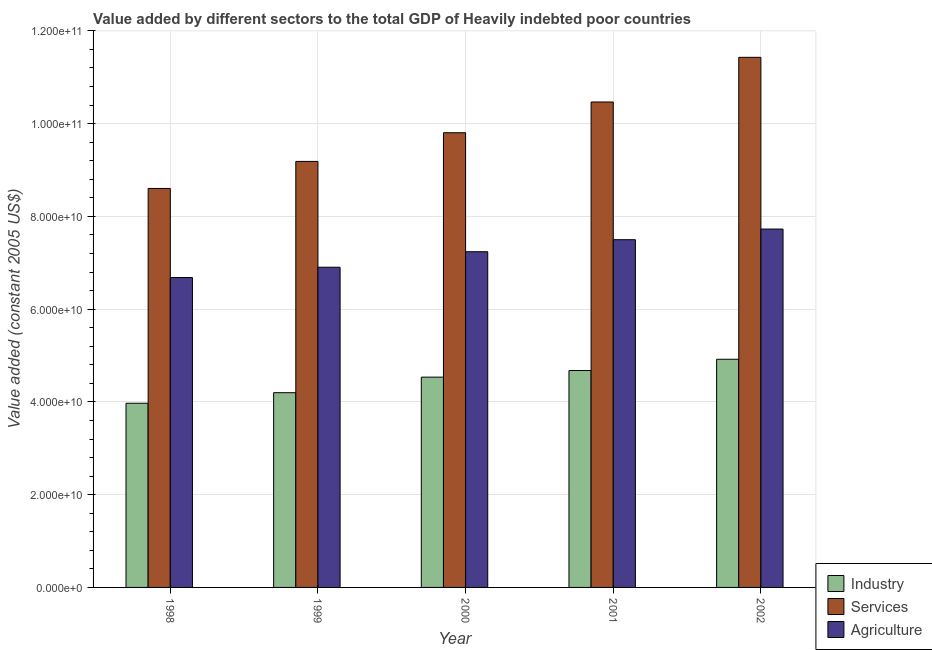How many different coloured bars are there?
Offer a terse response. 3. Are the number of bars per tick equal to the number of legend labels?
Ensure brevity in your answer.  Yes. Are the number of bars on each tick of the X-axis equal?
Your answer should be compact. Yes. What is the label of the 5th group of bars from the left?
Your answer should be very brief. 2002. What is the value added by agricultural sector in 1998?
Provide a succinct answer. 6.68e+1. Across all years, what is the maximum value added by industrial sector?
Make the answer very short. 4.92e+1. Across all years, what is the minimum value added by services?
Your answer should be very brief. 8.60e+1. In which year was the value added by services maximum?
Your response must be concise. 2002. In which year was the value added by industrial sector minimum?
Offer a very short reply. 1998. What is the total value added by agricultural sector in the graph?
Offer a very short reply. 3.60e+11. What is the difference between the value added by agricultural sector in 1999 and that in 2002?
Give a very brief answer. -8.23e+09. What is the difference between the value added by services in 2000 and the value added by agricultural sector in 1999?
Your response must be concise. 6.18e+09. What is the average value added by industrial sector per year?
Offer a terse response. 4.46e+1. In the year 2001, what is the difference between the value added by agricultural sector and value added by services?
Provide a short and direct response. 0. What is the ratio of the value added by industrial sector in 1998 to that in 2000?
Offer a terse response. 0.88. Is the value added by agricultural sector in 1998 less than that in 2001?
Provide a short and direct response. Yes. What is the difference between the highest and the second highest value added by industrial sector?
Provide a short and direct response. 2.43e+09. What is the difference between the highest and the lowest value added by industrial sector?
Provide a succinct answer. 9.49e+09. In how many years, is the value added by industrial sector greater than the average value added by industrial sector taken over all years?
Make the answer very short. 3. What does the 2nd bar from the left in 1999 represents?
Ensure brevity in your answer.  Services. What does the 1st bar from the right in 1999 represents?
Offer a very short reply. Agriculture. Is it the case that in every year, the sum of the value added by industrial sector and value added by services is greater than the value added by agricultural sector?
Give a very brief answer. Yes. Are all the bars in the graph horizontal?
Offer a very short reply. No. Are the values on the major ticks of Y-axis written in scientific E-notation?
Provide a short and direct response. Yes. Does the graph contain grids?
Your answer should be compact. Yes. How many legend labels are there?
Keep it short and to the point. 3. What is the title of the graph?
Your answer should be compact. Value added by different sectors to the total GDP of Heavily indebted poor countries. What is the label or title of the X-axis?
Make the answer very short. Year. What is the label or title of the Y-axis?
Ensure brevity in your answer.  Value added (constant 2005 US$). What is the Value added (constant 2005 US$) in Industry in 1998?
Offer a terse response. 3.97e+1. What is the Value added (constant 2005 US$) in Services in 1998?
Your response must be concise. 8.60e+1. What is the Value added (constant 2005 US$) of Agriculture in 1998?
Your answer should be very brief. 6.68e+1. What is the Value added (constant 2005 US$) in Industry in 1999?
Make the answer very short. 4.20e+1. What is the Value added (constant 2005 US$) in Services in 1999?
Ensure brevity in your answer.  9.19e+1. What is the Value added (constant 2005 US$) in Agriculture in 1999?
Offer a very short reply. 6.90e+1. What is the Value added (constant 2005 US$) of Industry in 2000?
Offer a terse response. 4.53e+1. What is the Value added (constant 2005 US$) in Services in 2000?
Offer a terse response. 9.80e+1. What is the Value added (constant 2005 US$) in Agriculture in 2000?
Offer a very short reply. 7.24e+1. What is the Value added (constant 2005 US$) in Industry in 2001?
Ensure brevity in your answer.  4.68e+1. What is the Value added (constant 2005 US$) in Services in 2001?
Give a very brief answer. 1.05e+11. What is the Value added (constant 2005 US$) in Agriculture in 2001?
Provide a succinct answer. 7.50e+1. What is the Value added (constant 2005 US$) of Industry in 2002?
Your response must be concise. 4.92e+1. What is the Value added (constant 2005 US$) of Services in 2002?
Provide a succinct answer. 1.14e+11. What is the Value added (constant 2005 US$) in Agriculture in 2002?
Ensure brevity in your answer.  7.73e+1. Across all years, what is the maximum Value added (constant 2005 US$) of Industry?
Give a very brief answer. 4.92e+1. Across all years, what is the maximum Value added (constant 2005 US$) of Services?
Make the answer very short. 1.14e+11. Across all years, what is the maximum Value added (constant 2005 US$) in Agriculture?
Offer a very short reply. 7.73e+1. Across all years, what is the minimum Value added (constant 2005 US$) of Industry?
Your response must be concise. 3.97e+1. Across all years, what is the minimum Value added (constant 2005 US$) of Services?
Keep it short and to the point. 8.60e+1. Across all years, what is the minimum Value added (constant 2005 US$) in Agriculture?
Provide a succinct answer. 6.68e+1. What is the total Value added (constant 2005 US$) of Industry in the graph?
Your answer should be very brief. 2.23e+11. What is the total Value added (constant 2005 US$) of Services in the graph?
Your response must be concise. 4.95e+11. What is the total Value added (constant 2005 US$) in Agriculture in the graph?
Offer a very short reply. 3.60e+11. What is the difference between the Value added (constant 2005 US$) in Industry in 1998 and that in 1999?
Provide a short and direct response. -2.28e+09. What is the difference between the Value added (constant 2005 US$) of Services in 1998 and that in 1999?
Provide a succinct answer. -5.83e+09. What is the difference between the Value added (constant 2005 US$) in Agriculture in 1998 and that in 1999?
Ensure brevity in your answer.  -2.22e+09. What is the difference between the Value added (constant 2005 US$) in Industry in 1998 and that in 2000?
Your answer should be very brief. -5.63e+09. What is the difference between the Value added (constant 2005 US$) of Services in 1998 and that in 2000?
Offer a very short reply. -1.20e+1. What is the difference between the Value added (constant 2005 US$) of Agriculture in 1998 and that in 2000?
Your response must be concise. -5.57e+09. What is the difference between the Value added (constant 2005 US$) of Industry in 1998 and that in 2001?
Keep it short and to the point. -7.06e+09. What is the difference between the Value added (constant 2005 US$) in Services in 1998 and that in 2001?
Offer a terse response. -1.86e+1. What is the difference between the Value added (constant 2005 US$) of Agriculture in 1998 and that in 2001?
Offer a terse response. -8.16e+09. What is the difference between the Value added (constant 2005 US$) in Industry in 1998 and that in 2002?
Your answer should be compact. -9.49e+09. What is the difference between the Value added (constant 2005 US$) of Services in 1998 and that in 2002?
Make the answer very short. -2.83e+1. What is the difference between the Value added (constant 2005 US$) in Agriculture in 1998 and that in 2002?
Provide a short and direct response. -1.05e+1. What is the difference between the Value added (constant 2005 US$) of Industry in 1999 and that in 2000?
Your response must be concise. -3.35e+09. What is the difference between the Value added (constant 2005 US$) in Services in 1999 and that in 2000?
Keep it short and to the point. -6.18e+09. What is the difference between the Value added (constant 2005 US$) of Agriculture in 1999 and that in 2000?
Your response must be concise. -3.34e+09. What is the difference between the Value added (constant 2005 US$) in Industry in 1999 and that in 2001?
Your answer should be very brief. -4.78e+09. What is the difference between the Value added (constant 2005 US$) of Services in 1999 and that in 2001?
Provide a succinct answer. -1.28e+1. What is the difference between the Value added (constant 2005 US$) in Agriculture in 1999 and that in 2001?
Your answer should be very brief. -5.93e+09. What is the difference between the Value added (constant 2005 US$) of Industry in 1999 and that in 2002?
Give a very brief answer. -7.21e+09. What is the difference between the Value added (constant 2005 US$) of Services in 1999 and that in 2002?
Offer a terse response. -2.24e+1. What is the difference between the Value added (constant 2005 US$) of Agriculture in 1999 and that in 2002?
Provide a short and direct response. -8.23e+09. What is the difference between the Value added (constant 2005 US$) of Industry in 2000 and that in 2001?
Offer a terse response. -1.43e+09. What is the difference between the Value added (constant 2005 US$) in Services in 2000 and that in 2001?
Give a very brief answer. -6.63e+09. What is the difference between the Value added (constant 2005 US$) of Agriculture in 2000 and that in 2001?
Provide a succinct answer. -2.59e+09. What is the difference between the Value added (constant 2005 US$) in Industry in 2000 and that in 2002?
Provide a succinct answer. -3.85e+09. What is the difference between the Value added (constant 2005 US$) in Services in 2000 and that in 2002?
Offer a very short reply. -1.63e+1. What is the difference between the Value added (constant 2005 US$) in Agriculture in 2000 and that in 2002?
Offer a very short reply. -4.89e+09. What is the difference between the Value added (constant 2005 US$) in Industry in 2001 and that in 2002?
Keep it short and to the point. -2.43e+09. What is the difference between the Value added (constant 2005 US$) of Services in 2001 and that in 2002?
Your answer should be compact. -9.63e+09. What is the difference between the Value added (constant 2005 US$) in Agriculture in 2001 and that in 2002?
Offer a very short reply. -2.30e+09. What is the difference between the Value added (constant 2005 US$) of Industry in 1998 and the Value added (constant 2005 US$) of Services in 1999?
Ensure brevity in your answer.  -5.21e+1. What is the difference between the Value added (constant 2005 US$) of Industry in 1998 and the Value added (constant 2005 US$) of Agriculture in 1999?
Offer a very short reply. -2.93e+1. What is the difference between the Value added (constant 2005 US$) of Services in 1998 and the Value added (constant 2005 US$) of Agriculture in 1999?
Provide a succinct answer. 1.70e+1. What is the difference between the Value added (constant 2005 US$) in Industry in 1998 and the Value added (constant 2005 US$) in Services in 2000?
Provide a succinct answer. -5.83e+1. What is the difference between the Value added (constant 2005 US$) in Industry in 1998 and the Value added (constant 2005 US$) in Agriculture in 2000?
Keep it short and to the point. -3.27e+1. What is the difference between the Value added (constant 2005 US$) in Services in 1998 and the Value added (constant 2005 US$) in Agriculture in 2000?
Make the answer very short. 1.36e+1. What is the difference between the Value added (constant 2005 US$) of Industry in 1998 and the Value added (constant 2005 US$) of Services in 2001?
Offer a very short reply. -6.50e+1. What is the difference between the Value added (constant 2005 US$) in Industry in 1998 and the Value added (constant 2005 US$) in Agriculture in 2001?
Offer a very short reply. -3.53e+1. What is the difference between the Value added (constant 2005 US$) in Services in 1998 and the Value added (constant 2005 US$) in Agriculture in 2001?
Your answer should be very brief. 1.11e+1. What is the difference between the Value added (constant 2005 US$) in Industry in 1998 and the Value added (constant 2005 US$) in Services in 2002?
Provide a succinct answer. -7.46e+1. What is the difference between the Value added (constant 2005 US$) in Industry in 1998 and the Value added (constant 2005 US$) in Agriculture in 2002?
Provide a short and direct response. -3.76e+1. What is the difference between the Value added (constant 2005 US$) in Services in 1998 and the Value added (constant 2005 US$) in Agriculture in 2002?
Provide a succinct answer. 8.76e+09. What is the difference between the Value added (constant 2005 US$) of Industry in 1999 and the Value added (constant 2005 US$) of Services in 2000?
Keep it short and to the point. -5.60e+1. What is the difference between the Value added (constant 2005 US$) of Industry in 1999 and the Value added (constant 2005 US$) of Agriculture in 2000?
Give a very brief answer. -3.04e+1. What is the difference between the Value added (constant 2005 US$) of Services in 1999 and the Value added (constant 2005 US$) of Agriculture in 2000?
Provide a succinct answer. 1.95e+1. What is the difference between the Value added (constant 2005 US$) in Industry in 1999 and the Value added (constant 2005 US$) in Services in 2001?
Your answer should be compact. -6.27e+1. What is the difference between the Value added (constant 2005 US$) of Industry in 1999 and the Value added (constant 2005 US$) of Agriculture in 2001?
Your response must be concise. -3.30e+1. What is the difference between the Value added (constant 2005 US$) of Services in 1999 and the Value added (constant 2005 US$) of Agriculture in 2001?
Offer a very short reply. 1.69e+1. What is the difference between the Value added (constant 2005 US$) of Industry in 1999 and the Value added (constant 2005 US$) of Services in 2002?
Your answer should be very brief. -7.23e+1. What is the difference between the Value added (constant 2005 US$) of Industry in 1999 and the Value added (constant 2005 US$) of Agriculture in 2002?
Provide a succinct answer. -3.53e+1. What is the difference between the Value added (constant 2005 US$) of Services in 1999 and the Value added (constant 2005 US$) of Agriculture in 2002?
Make the answer very short. 1.46e+1. What is the difference between the Value added (constant 2005 US$) of Industry in 2000 and the Value added (constant 2005 US$) of Services in 2001?
Give a very brief answer. -5.93e+1. What is the difference between the Value added (constant 2005 US$) in Industry in 2000 and the Value added (constant 2005 US$) in Agriculture in 2001?
Keep it short and to the point. -2.96e+1. What is the difference between the Value added (constant 2005 US$) of Services in 2000 and the Value added (constant 2005 US$) of Agriculture in 2001?
Ensure brevity in your answer.  2.31e+1. What is the difference between the Value added (constant 2005 US$) of Industry in 2000 and the Value added (constant 2005 US$) of Services in 2002?
Your response must be concise. -6.90e+1. What is the difference between the Value added (constant 2005 US$) of Industry in 2000 and the Value added (constant 2005 US$) of Agriculture in 2002?
Your response must be concise. -3.19e+1. What is the difference between the Value added (constant 2005 US$) in Services in 2000 and the Value added (constant 2005 US$) in Agriculture in 2002?
Your answer should be very brief. 2.08e+1. What is the difference between the Value added (constant 2005 US$) in Industry in 2001 and the Value added (constant 2005 US$) in Services in 2002?
Your answer should be compact. -6.75e+1. What is the difference between the Value added (constant 2005 US$) of Industry in 2001 and the Value added (constant 2005 US$) of Agriculture in 2002?
Your answer should be very brief. -3.05e+1. What is the difference between the Value added (constant 2005 US$) of Services in 2001 and the Value added (constant 2005 US$) of Agriculture in 2002?
Your answer should be compact. 2.74e+1. What is the average Value added (constant 2005 US$) in Industry per year?
Provide a succinct answer. 4.46e+1. What is the average Value added (constant 2005 US$) of Services per year?
Your response must be concise. 9.90e+1. What is the average Value added (constant 2005 US$) in Agriculture per year?
Your response must be concise. 7.21e+1. In the year 1998, what is the difference between the Value added (constant 2005 US$) in Industry and Value added (constant 2005 US$) in Services?
Provide a succinct answer. -4.63e+1. In the year 1998, what is the difference between the Value added (constant 2005 US$) of Industry and Value added (constant 2005 US$) of Agriculture?
Ensure brevity in your answer.  -2.71e+1. In the year 1998, what is the difference between the Value added (constant 2005 US$) of Services and Value added (constant 2005 US$) of Agriculture?
Give a very brief answer. 1.92e+1. In the year 1999, what is the difference between the Value added (constant 2005 US$) of Industry and Value added (constant 2005 US$) of Services?
Offer a very short reply. -4.99e+1. In the year 1999, what is the difference between the Value added (constant 2005 US$) of Industry and Value added (constant 2005 US$) of Agriculture?
Offer a terse response. -2.71e+1. In the year 1999, what is the difference between the Value added (constant 2005 US$) in Services and Value added (constant 2005 US$) in Agriculture?
Offer a very short reply. 2.28e+1. In the year 2000, what is the difference between the Value added (constant 2005 US$) in Industry and Value added (constant 2005 US$) in Services?
Offer a very short reply. -5.27e+1. In the year 2000, what is the difference between the Value added (constant 2005 US$) of Industry and Value added (constant 2005 US$) of Agriculture?
Ensure brevity in your answer.  -2.70e+1. In the year 2000, what is the difference between the Value added (constant 2005 US$) of Services and Value added (constant 2005 US$) of Agriculture?
Your answer should be compact. 2.57e+1. In the year 2001, what is the difference between the Value added (constant 2005 US$) in Industry and Value added (constant 2005 US$) in Services?
Offer a terse response. -5.79e+1. In the year 2001, what is the difference between the Value added (constant 2005 US$) of Industry and Value added (constant 2005 US$) of Agriculture?
Keep it short and to the point. -2.82e+1. In the year 2001, what is the difference between the Value added (constant 2005 US$) in Services and Value added (constant 2005 US$) in Agriculture?
Your answer should be compact. 2.97e+1. In the year 2002, what is the difference between the Value added (constant 2005 US$) in Industry and Value added (constant 2005 US$) in Services?
Keep it short and to the point. -6.51e+1. In the year 2002, what is the difference between the Value added (constant 2005 US$) of Industry and Value added (constant 2005 US$) of Agriculture?
Provide a succinct answer. -2.81e+1. In the year 2002, what is the difference between the Value added (constant 2005 US$) in Services and Value added (constant 2005 US$) in Agriculture?
Offer a very short reply. 3.70e+1. What is the ratio of the Value added (constant 2005 US$) in Industry in 1998 to that in 1999?
Offer a very short reply. 0.95. What is the ratio of the Value added (constant 2005 US$) in Services in 1998 to that in 1999?
Offer a terse response. 0.94. What is the ratio of the Value added (constant 2005 US$) in Agriculture in 1998 to that in 1999?
Give a very brief answer. 0.97. What is the ratio of the Value added (constant 2005 US$) in Industry in 1998 to that in 2000?
Provide a short and direct response. 0.88. What is the ratio of the Value added (constant 2005 US$) of Services in 1998 to that in 2000?
Your answer should be very brief. 0.88. What is the ratio of the Value added (constant 2005 US$) in Agriculture in 1998 to that in 2000?
Provide a short and direct response. 0.92. What is the ratio of the Value added (constant 2005 US$) in Industry in 1998 to that in 2001?
Make the answer very short. 0.85. What is the ratio of the Value added (constant 2005 US$) in Services in 1998 to that in 2001?
Offer a very short reply. 0.82. What is the ratio of the Value added (constant 2005 US$) of Agriculture in 1998 to that in 2001?
Ensure brevity in your answer.  0.89. What is the ratio of the Value added (constant 2005 US$) of Industry in 1998 to that in 2002?
Ensure brevity in your answer.  0.81. What is the ratio of the Value added (constant 2005 US$) in Services in 1998 to that in 2002?
Your answer should be compact. 0.75. What is the ratio of the Value added (constant 2005 US$) of Agriculture in 1998 to that in 2002?
Provide a succinct answer. 0.86. What is the ratio of the Value added (constant 2005 US$) of Industry in 1999 to that in 2000?
Keep it short and to the point. 0.93. What is the ratio of the Value added (constant 2005 US$) of Services in 1999 to that in 2000?
Keep it short and to the point. 0.94. What is the ratio of the Value added (constant 2005 US$) of Agriculture in 1999 to that in 2000?
Ensure brevity in your answer.  0.95. What is the ratio of the Value added (constant 2005 US$) in Industry in 1999 to that in 2001?
Your response must be concise. 0.9. What is the ratio of the Value added (constant 2005 US$) in Services in 1999 to that in 2001?
Offer a terse response. 0.88. What is the ratio of the Value added (constant 2005 US$) in Agriculture in 1999 to that in 2001?
Make the answer very short. 0.92. What is the ratio of the Value added (constant 2005 US$) of Industry in 1999 to that in 2002?
Make the answer very short. 0.85. What is the ratio of the Value added (constant 2005 US$) of Services in 1999 to that in 2002?
Offer a terse response. 0.8. What is the ratio of the Value added (constant 2005 US$) of Agriculture in 1999 to that in 2002?
Your response must be concise. 0.89. What is the ratio of the Value added (constant 2005 US$) in Industry in 2000 to that in 2001?
Your answer should be very brief. 0.97. What is the ratio of the Value added (constant 2005 US$) of Services in 2000 to that in 2001?
Provide a short and direct response. 0.94. What is the ratio of the Value added (constant 2005 US$) in Agriculture in 2000 to that in 2001?
Provide a succinct answer. 0.97. What is the ratio of the Value added (constant 2005 US$) in Industry in 2000 to that in 2002?
Give a very brief answer. 0.92. What is the ratio of the Value added (constant 2005 US$) of Services in 2000 to that in 2002?
Provide a short and direct response. 0.86. What is the ratio of the Value added (constant 2005 US$) in Agriculture in 2000 to that in 2002?
Your response must be concise. 0.94. What is the ratio of the Value added (constant 2005 US$) in Industry in 2001 to that in 2002?
Your answer should be compact. 0.95. What is the ratio of the Value added (constant 2005 US$) in Services in 2001 to that in 2002?
Make the answer very short. 0.92. What is the ratio of the Value added (constant 2005 US$) of Agriculture in 2001 to that in 2002?
Ensure brevity in your answer.  0.97. What is the difference between the highest and the second highest Value added (constant 2005 US$) in Industry?
Offer a terse response. 2.43e+09. What is the difference between the highest and the second highest Value added (constant 2005 US$) in Services?
Your response must be concise. 9.63e+09. What is the difference between the highest and the second highest Value added (constant 2005 US$) of Agriculture?
Provide a succinct answer. 2.30e+09. What is the difference between the highest and the lowest Value added (constant 2005 US$) of Industry?
Keep it short and to the point. 9.49e+09. What is the difference between the highest and the lowest Value added (constant 2005 US$) in Services?
Provide a short and direct response. 2.83e+1. What is the difference between the highest and the lowest Value added (constant 2005 US$) in Agriculture?
Give a very brief answer. 1.05e+1. 